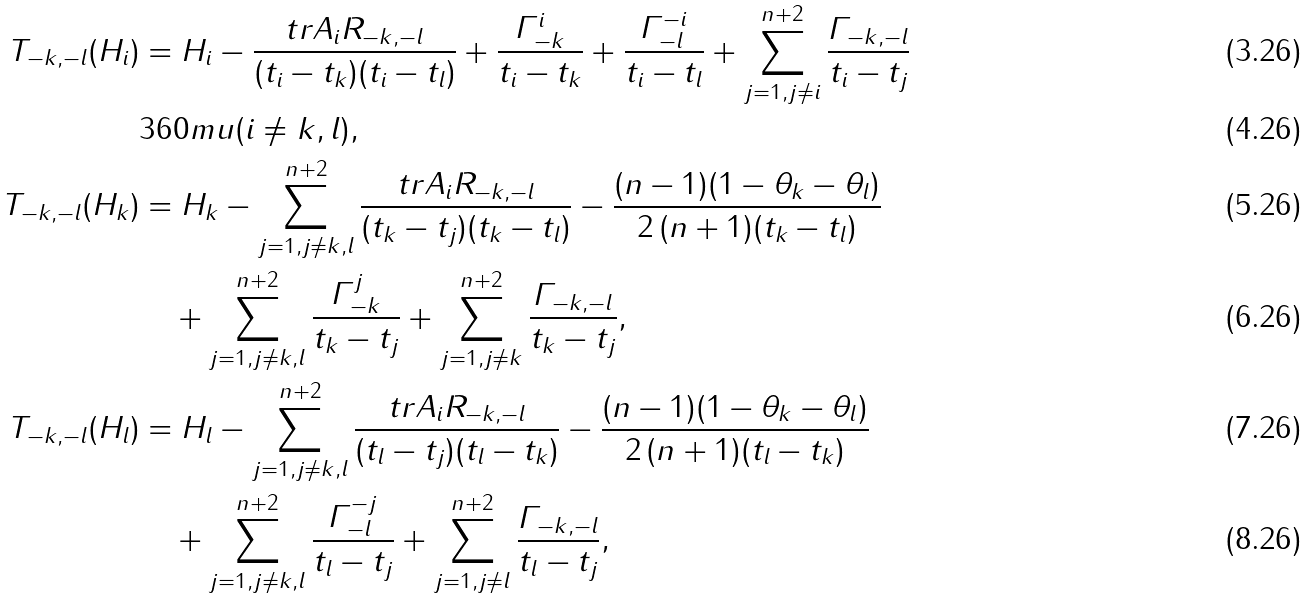Convert formula to latex. <formula><loc_0><loc_0><loc_500><loc_500>T _ { - k , - l } ( H _ { i } ) & = H _ { i } - \frac { t r A _ { i } R _ { - k , - l } } { ( t _ { i } - t _ { k } ) ( t _ { i } - t _ { l } ) } + \frac { \varGamma ^ { i } _ { - k } } { t _ { i } - t _ { k } } + \frac { \varGamma ^ { - i } _ { - l } } { t _ { i } - t _ { l } } + \sum _ { j = 1 , j \neq i } ^ { n + 2 } \frac { \varGamma _ { - k , - l } } { t _ { i } - t _ { j } } \\ & { 3 6 0 m u } ( i \neq k , l ) , \\ T _ { - k , - l } ( H _ { k } ) & = H _ { k } - \sum _ { j = 1 , j \neq k , l } ^ { n + 2 } \frac { t r A _ { i } R _ { - k , - l } } { ( t _ { k } - t _ { j } ) ( t _ { k } - t _ { l } ) } - \frac { ( n - 1 ) ( 1 - \theta _ { k } - \theta _ { l } ) } { 2 \, ( n + 1 ) ( t _ { k } - t _ { l } ) } \\ & \quad + \sum _ { j = 1 , j \neq k , l } ^ { n + 2 } \frac { \varGamma ^ { j } _ { - k } } { t _ { k } - t _ { j } } + \sum _ { j = 1 , j \neq k } ^ { n + 2 } \frac { \varGamma _ { - k , - l } } { t _ { k } - t _ { j } } , \\ T _ { - k , - l } ( H _ { l } ) & = H _ { l } - \sum _ { j = 1 , j \neq k , l } ^ { n + 2 } \frac { t r A _ { i } R _ { - k , - l } } { ( t _ { l } - t _ { j } ) ( t _ { l } - t _ { k } ) } - \frac { ( n - 1 ) ( 1 - \theta _ { k } - \theta _ { l } ) } { 2 \, ( n + 1 ) ( t _ { l } - t _ { k } ) } \\ & \quad + \sum _ { j = 1 , j \neq k , l } ^ { n + 2 } \frac { \varGamma ^ { - j } _ { - l } } { t _ { l } - t _ { j } } + \sum _ { j = 1 , j \neq l } ^ { n + 2 } \frac { \varGamma _ { - k , - l } } { t _ { l } - t _ { j } } ,</formula> 